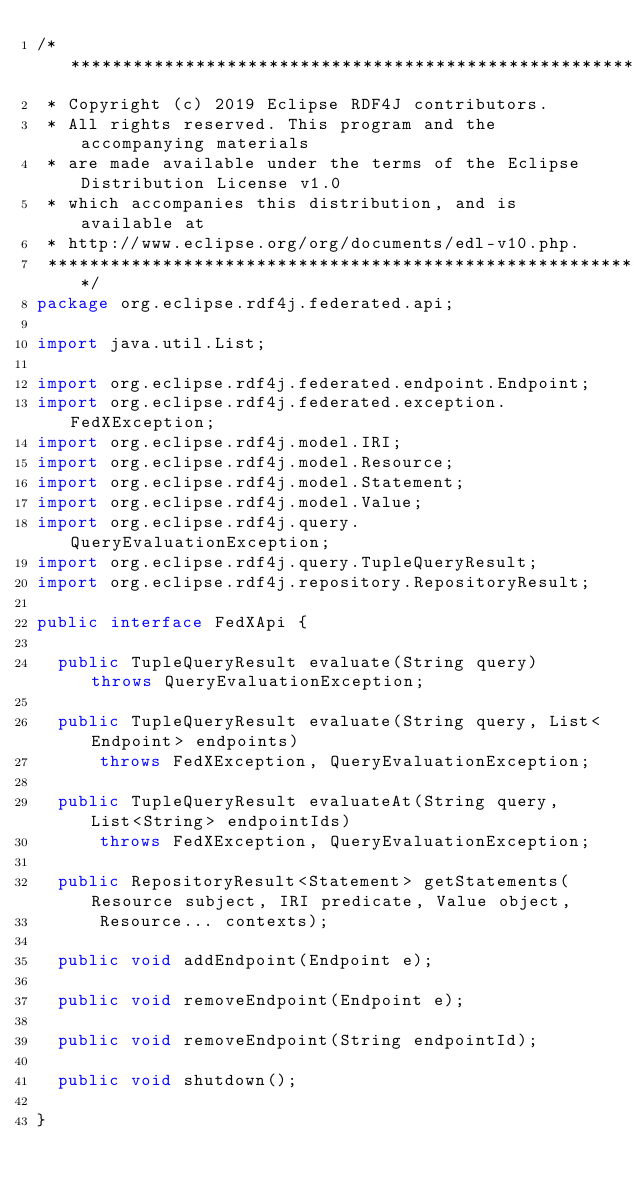<code> <loc_0><loc_0><loc_500><loc_500><_Java_>/*******************************************************************************
 * Copyright (c) 2019 Eclipse RDF4J contributors.
 * All rights reserved. This program and the accompanying materials
 * are made available under the terms of the Eclipse Distribution License v1.0
 * which accompanies this distribution, and is available at
 * http://www.eclipse.org/org/documents/edl-v10.php.
 *******************************************************************************/
package org.eclipse.rdf4j.federated.api;

import java.util.List;

import org.eclipse.rdf4j.federated.endpoint.Endpoint;
import org.eclipse.rdf4j.federated.exception.FedXException;
import org.eclipse.rdf4j.model.IRI;
import org.eclipse.rdf4j.model.Resource;
import org.eclipse.rdf4j.model.Statement;
import org.eclipse.rdf4j.model.Value;
import org.eclipse.rdf4j.query.QueryEvaluationException;
import org.eclipse.rdf4j.query.TupleQueryResult;
import org.eclipse.rdf4j.repository.RepositoryResult;

public interface FedXApi {

	public TupleQueryResult evaluate(String query) throws QueryEvaluationException;

	public TupleQueryResult evaluate(String query, List<Endpoint> endpoints)
			throws FedXException, QueryEvaluationException;

	public TupleQueryResult evaluateAt(String query, List<String> endpointIds)
			throws FedXException, QueryEvaluationException;

	public RepositoryResult<Statement> getStatements(Resource subject, IRI predicate, Value object,
			Resource... contexts);

	public void addEndpoint(Endpoint e);

	public void removeEndpoint(Endpoint e);

	public void removeEndpoint(String endpointId);

	public void shutdown();

}
</code> 